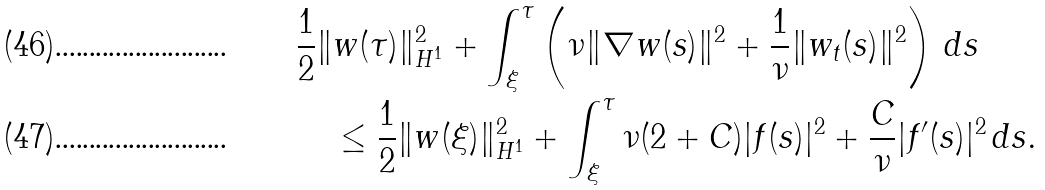<formula> <loc_0><loc_0><loc_500><loc_500>& \frac { 1 } { 2 } \| w ( \tau ) \| _ { H ^ { 1 } } ^ { 2 } + \int _ { \xi } ^ { \tau } \left ( \nu \| \nabla w ( s ) \| ^ { 2 } + \frac { 1 } { \nu } \| w _ { t } ( s ) \| ^ { 2 } \right ) \, d s \\ & \quad \leq \frac { 1 } { 2 } \| w ( \xi ) \| _ { H ^ { 1 } } ^ { 2 } + \int _ { \xi } ^ { \tau } \nu ( 2 + C ) | f ( s ) | ^ { 2 } + \frac { C } { \nu } | f ^ { \prime } ( s ) | ^ { 2 } \, d s .</formula> 